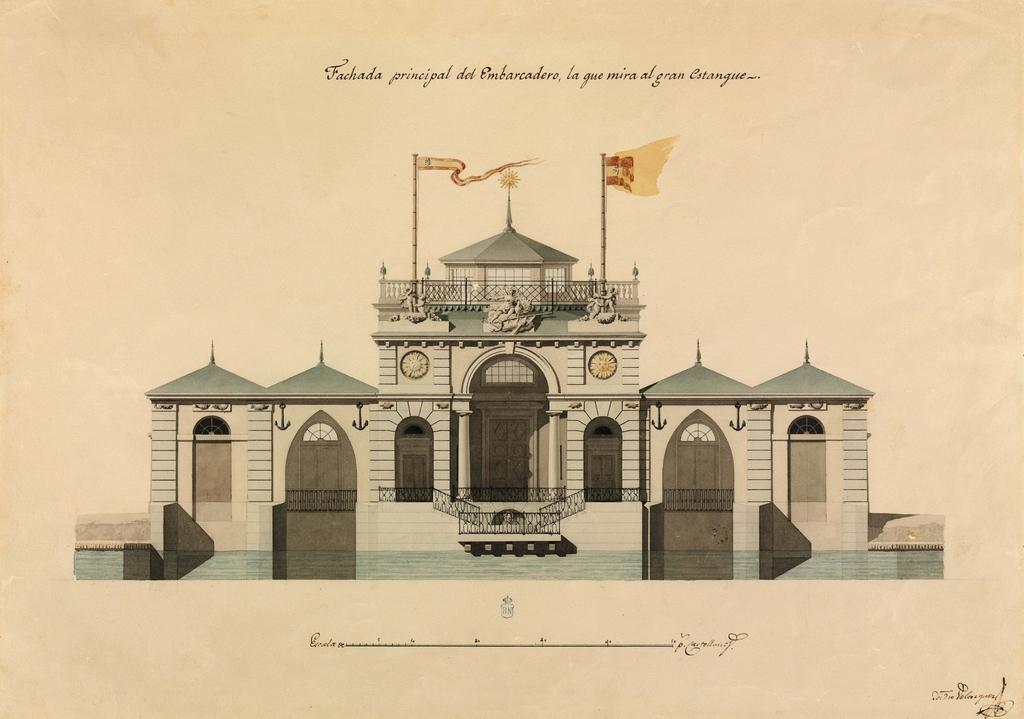How would you summarize this image in a sentence or two? In this image there is a paper and we can see a picture of a building printed on the paper. There is text. 